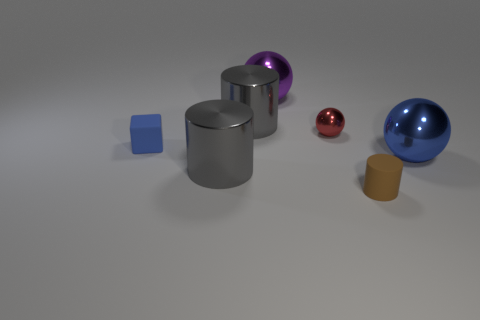Subtract all gray cylinders. How many cylinders are left? 1 Add 3 big purple shiny balls. How many objects exist? 10 Subtract all gray cylinders. How many cylinders are left? 1 Subtract all blocks. How many objects are left? 6 Subtract 1 cylinders. How many cylinders are left? 2 Subtract 0 red cubes. How many objects are left? 7 Subtract all brown cubes. Subtract all purple cylinders. How many cubes are left? 1 Subtract all gray balls. How many blue cylinders are left? 0 Subtract all blue metallic objects. Subtract all tiny matte cubes. How many objects are left? 5 Add 2 small blue blocks. How many small blue blocks are left? 3 